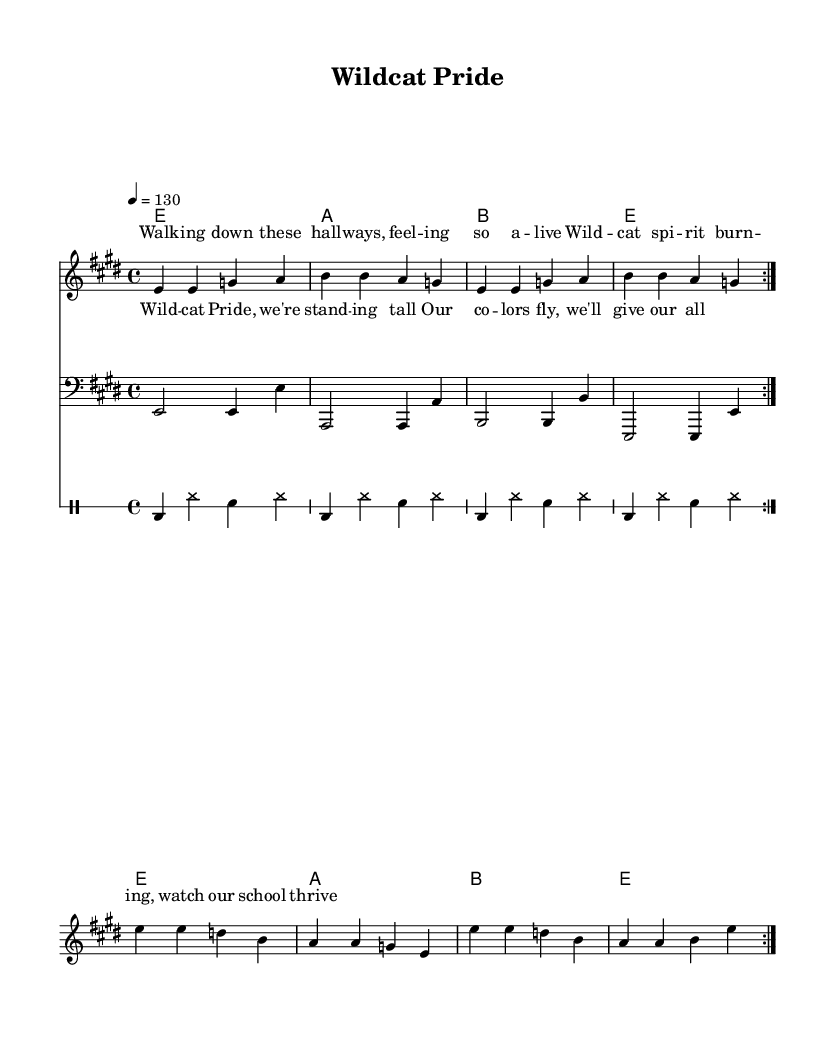What is the key signature of this music? The key signature is E major, which has four sharps: F#, C#, G#, and D#. This can be determined by looking at the key signature symbol at the beginning of the staff.
Answer: E major What is the time signature of this music? The time signature is 4/4, indicated by the notation placed at the beginning of the score. This signifies that there are four beats in each measure and a quarter note gets one beat.
Answer: 4/4 What is the tempo marking for this piece? The tempo is marked as 130 beats per minute, which is indicated by the tempo marking at the beginning of the score. This provides the speed at which the piece should be performed.
Answer: 130 How many times is the melody repeated in this composition? The melody is repeated twice, as indicated by the "volta" markings, which denote that the section should be played two times.
Answer: 2 What is the primary theme depicted in the lyrics of this song? The lyrics depict school spirit and pride, emphasizing the feeling of being alive in the school environment and celebrating Wildcat pride. This is evident through key phrases in the lyrics provided under the melody.
Answer: School spirit What type of rhythm is predominantly used in the drum part? The drum part features a steady backbeat characterized by a bass drum on the first beat and snare drum on the second and fourth beats, typical of a rock beat. This can be identified in the drum notation provided in the score.
Answer: Rock beat What instrument plays the bass line in this score? The bass line is played by the bass guitar, which is indicated by the staff clef marking as "bass." The notes in the bass line also reflect the typical sound and playing style associated with electric blues rock.
Answer: Bass guitar 